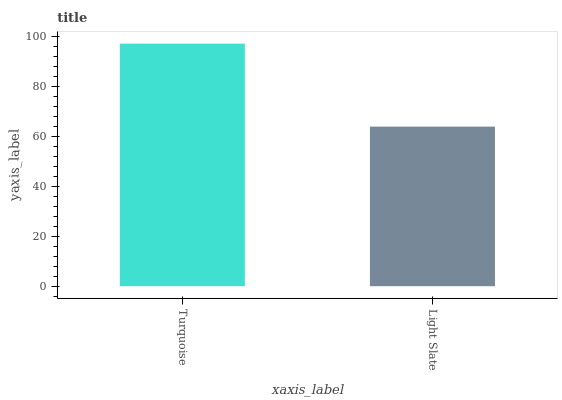Is Light Slate the minimum?
Answer yes or no. Yes. Is Turquoise the maximum?
Answer yes or no. Yes. Is Light Slate the maximum?
Answer yes or no. No. Is Turquoise greater than Light Slate?
Answer yes or no. Yes. Is Light Slate less than Turquoise?
Answer yes or no. Yes. Is Light Slate greater than Turquoise?
Answer yes or no. No. Is Turquoise less than Light Slate?
Answer yes or no. No. Is Turquoise the high median?
Answer yes or no. Yes. Is Light Slate the low median?
Answer yes or no. Yes. Is Light Slate the high median?
Answer yes or no. No. Is Turquoise the low median?
Answer yes or no. No. 